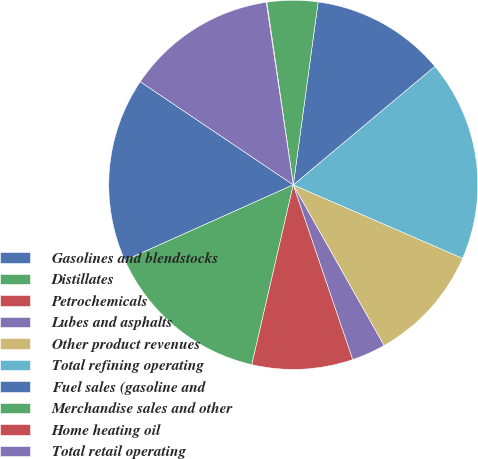Convert chart to OTSL. <chart><loc_0><loc_0><loc_500><loc_500><pie_chart><fcel>Gasolines and blendstocks<fcel>Distillates<fcel>Petrochemicals<fcel>Lubes and asphalts<fcel>Other product revenues<fcel>Total refining operating<fcel>Fuel sales (gasoline and<fcel>Merchandise sales and other<fcel>Home heating oil<fcel>Total retail operating<nl><fcel>16.15%<fcel>14.68%<fcel>8.83%<fcel>2.97%<fcel>10.29%<fcel>17.61%<fcel>11.76%<fcel>4.44%<fcel>0.05%<fcel>13.22%<nl></chart> 